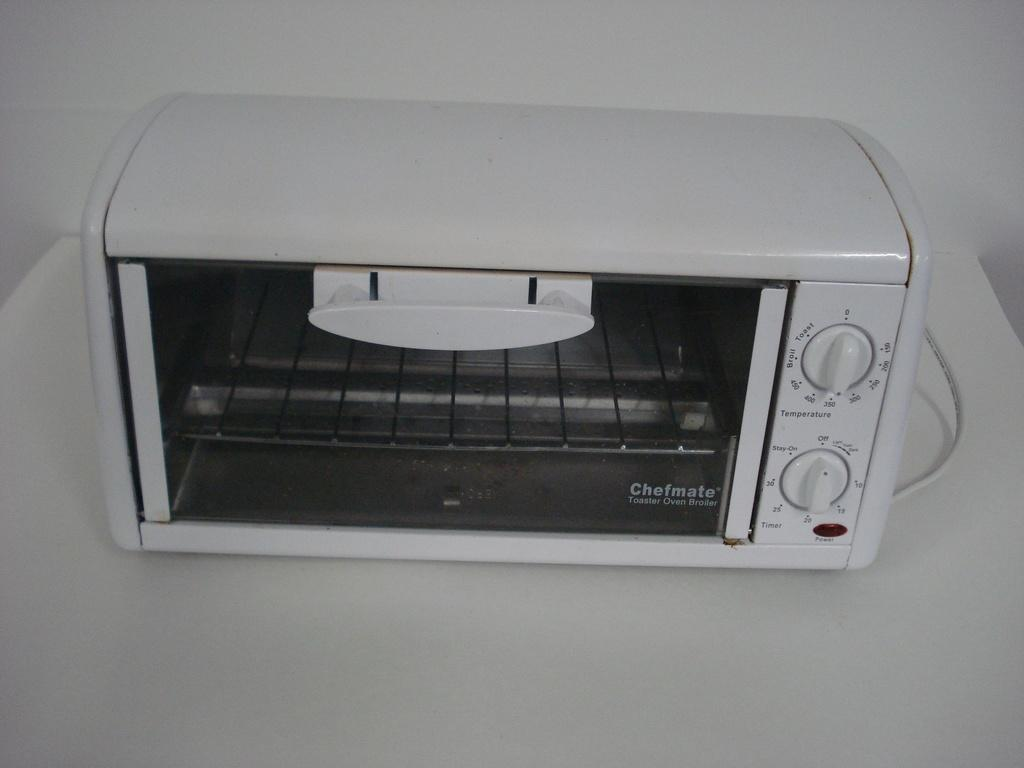What is the primary color of the object in the image? The primary color of the object in the image is white. What appliance can be seen on the white object? There is a white oven on the white object. What type of sail is attached to the white object in the image? There is no sail present in the image; it features a white object with a white oven on it. What is the condition of the white object in the image? The condition of the white object cannot be determined from the image alone, as it only shows the object and the oven. 